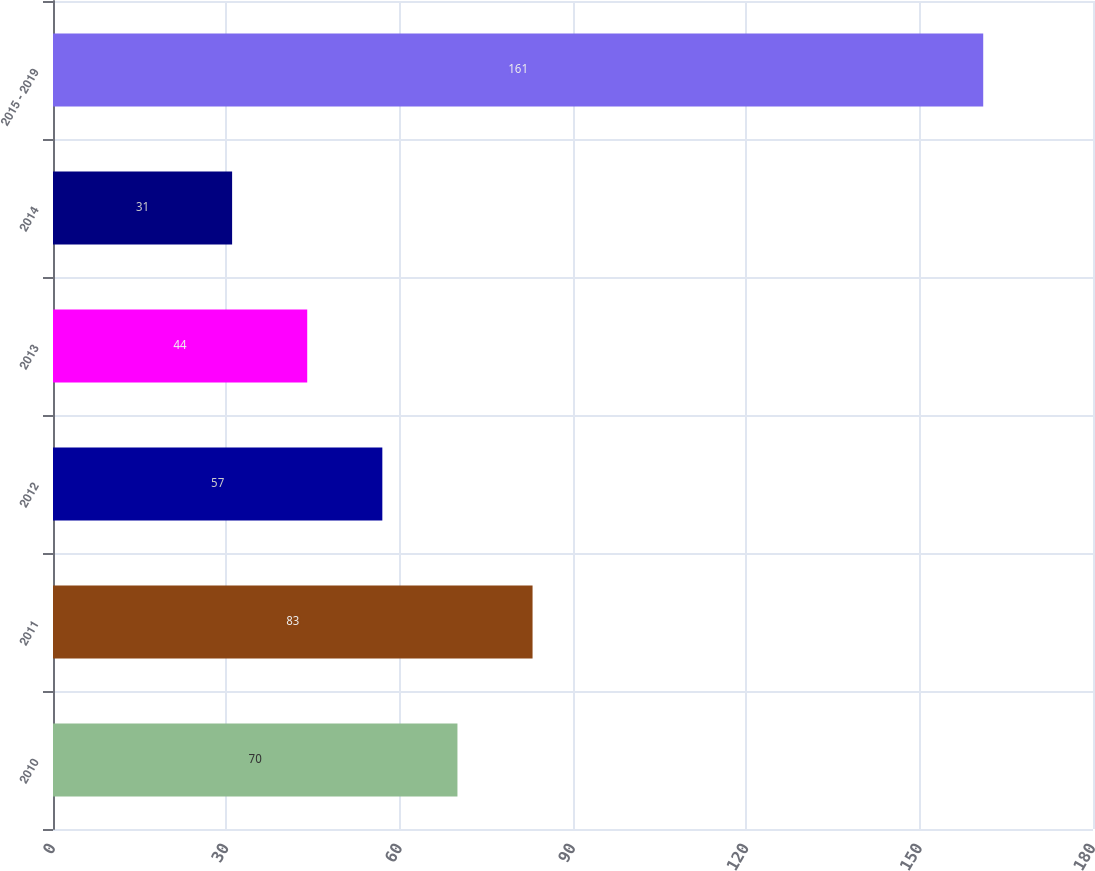Convert chart to OTSL. <chart><loc_0><loc_0><loc_500><loc_500><bar_chart><fcel>2010<fcel>2011<fcel>2012<fcel>2013<fcel>2014<fcel>2015 - 2019<nl><fcel>70<fcel>83<fcel>57<fcel>44<fcel>31<fcel>161<nl></chart> 